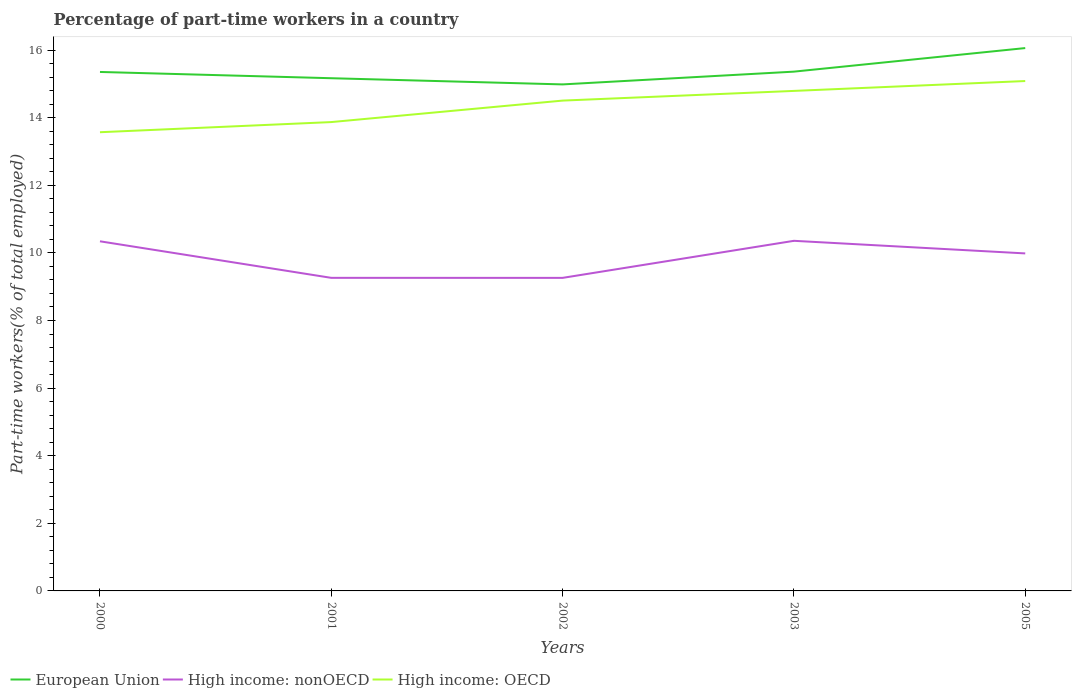Does the line corresponding to European Union intersect with the line corresponding to High income: nonOECD?
Keep it short and to the point. No. Across all years, what is the maximum percentage of part-time workers in European Union?
Give a very brief answer. 14.98. What is the total percentage of part-time workers in High income: nonOECD in the graph?
Keep it short and to the point. -1.1. What is the difference between the highest and the second highest percentage of part-time workers in European Union?
Offer a very short reply. 1.08. What is the difference between the highest and the lowest percentage of part-time workers in European Union?
Offer a very short reply. 1. How many years are there in the graph?
Your answer should be very brief. 5. What is the difference between two consecutive major ticks on the Y-axis?
Your answer should be compact. 2. Are the values on the major ticks of Y-axis written in scientific E-notation?
Offer a very short reply. No. Does the graph contain any zero values?
Offer a very short reply. No. Does the graph contain grids?
Your answer should be very brief. No. Where does the legend appear in the graph?
Offer a very short reply. Bottom left. What is the title of the graph?
Provide a short and direct response. Percentage of part-time workers in a country. Does "Samoa" appear as one of the legend labels in the graph?
Ensure brevity in your answer.  No. What is the label or title of the Y-axis?
Make the answer very short. Part-time workers(% of total employed). What is the Part-time workers(% of total employed) of European Union in 2000?
Your answer should be very brief. 15.35. What is the Part-time workers(% of total employed) in High income: nonOECD in 2000?
Your answer should be very brief. 10.34. What is the Part-time workers(% of total employed) of High income: OECD in 2000?
Your answer should be compact. 13.57. What is the Part-time workers(% of total employed) of European Union in 2001?
Your answer should be very brief. 15.17. What is the Part-time workers(% of total employed) of High income: nonOECD in 2001?
Your response must be concise. 9.26. What is the Part-time workers(% of total employed) of High income: OECD in 2001?
Your response must be concise. 13.87. What is the Part-time workers(% of total employed) of European Union in 2002?
Provide a short and direct response. 14.98. What is the Part-time workers(% of total employed) of High income: nonOECD in 2002?
Your answer should be very brief. 9.26. What is the Part-time workers(% of total employed) of High income: OECD in 2002?
Your answer should be very brief. 14.51. What is the Part-time workers(% of total employed) of European Union in 2003?
Make the answer very short. 15.36. What is the Part-time workers(% of total employed) in High income: nonOECD in 2003?
Your answer should be very brief. 10.36. What is the Part-time workers(% of total employed) in High income: OECD in 2003?
Provide a short and direct response. 14.79. What is the Part-time workers(% of total employed) in European Union in 2005?
Keep it short and to the point. 16.06. What is the Part-time workers(% of total employed) of High income: nonOECD in 2005?
Ensure brevity in your answer.  9.98. What is the Part-time workers(% of total employed) of High income: OECD in 2005?
Your response must be concise. 15.08. Across all years, what is the maximum Part-time workers(% of total employed) of European Union?
Keep it short and to the point. 16.06. Across all years, what is the maximum Part-time workers(% of total employed) in High income: nonOECD?
Provide a succinct answer. 10.36. Across all years, what is the maximum Part-time workers(% of total employed) of High income: OECD?
Your answer should be very brief. 15.08. Across all years, what is the minimum Part-time workers(% of total employed) of European Union?
Offer a terse response. 14.98. Across all years, what is the minimum Part-time workers(% of total employed) in High income: nonOECD?
Your response must be concise. 9.26. Across all years, what is the minimum Part-time workers(% of total employed) in High income: OECD?
Provide a succinct answer. 13.57. What is the total Part-time workers(% of total employed) of European Union in the graph?
Offer a terse response. 76.92. What is the total Part-time workers(% of total employed) in High income: nonOECD in the graph?
Ensure brevity in your answer.  49.21. What is the total Part-time workers(% of total employed) in High income: OECD in the graph?
Provide a short and direct response. 71.82. What is the difference between the Part-time workers(% of total employed) in European Union in 2000 and that in 2001?
Make the answer very short. 0.19. What is the difference between the Part-time workers(% of total employed) in High income: nonOECD in 2000 and that in 2001?
Your answer should be compact. 1.08. What is the difference between the Part-time workers(% of total employed) in High income: OECD in 2000 and that in 2001?
Provide a short and direct response. -0.3. What is the difference between the Part-time workers(% of total employed) in European Union in 2000 and that in 2002?
Provide a short and direct response. 0.37. What is the difference between the Part-time workers(% of total employed) in High income: nonOECD in 2000 and that in 2002?
Make the answer very short. 1.08. What is the difference between the Part-time workers(% of total employed) of High income: OECD in 2000 and that in 2002?
Your answer should be compact. -0.94. What is the difference between the Part-time workers(% of total employed) of European Union in 2000 and that in 2003?
Offer a terse response. -0.01. What is the difference between the Part-time workers(% of total employed) of High income: nonOECD in 2000 and that in 2003?
Offer a terse response. -0.01. What is the difference between the Part-time workers(% of total employed) in High income: OECD in 2000 and that in 2003?
Make the answer very short. -1.22. What is the difference between the Part-time workers(% of total employed) in European Union in 2000 and that in 2005?
Offer a terse response. -0.71. What is the difference between the Part-time workers(% of total employed) in High income: nonOECD in 2000 and that in 2005?
Your response must be concise. 0.36. What is the difference between the Part-time workers(% of total employed) in High income: OECD in 2000 and that in 2005?
Give a very brief answer. -1.51. What is the difference between the Part-time workers(% of total employed) in European Union in 2001 and that in 2002?
Make the answer very short. 0.18. What is the difference between the Part-time workers(% of total employed) in High income: nonOECD in 2001 and that in 2002?
Ensure brevity in your answer.  0. What is the difference between the Part-time workers(% of total employed) in High income: OECD in 2001 and that in 2002?
Your answer should be compact. -0.64. What is the difference between the Part-time workers(% of total employed) in European Union in 2001 and that in 2003?
Your answer should be very brief. -0.19. What is the difference between the Part-time workers(% of total employed) of High income: nonOECD in 2001 and that in 2003?
Keep it short and to the point. -1.1. What is the difference between the Part-time workers(% of total employed) in High income: OECD in 2001 and that in 2003?
Your answer should be compact. -0.92. What is the difference between the Part-time workers(% of total employed) of European Union in 2001 and that in 2005?
Provide a succinct answer. -0.89. What is the difference between the Part-time workers(% of total employed) in High income: nonOECD in 2001 and that in 2005?
Your answer should be compact. -0.72. What is the difference between the Part-time workers(% of total employed) in High income: OECD in 2001 and that in 2005?
Ensure brevity in your answer.  -1.21. What is the difference between the Part-time workers(% of total employed) of European Union in 2002 and that in 2003?
Offer a very short reply. -0.38. What is the difference between the Part-time workers(% of total employed) of High income: nonOECD in 2002 and that in 2003?
Your response must be concise. -1.1. What is the difference between the Part-time workers(% of total employed) of High income: OECD in 2002 and that in 2003?
Give a very brief answer. -0.29. What is the difference between the Part-time workers(% of total employed) of European Union in 2002 and that in 2005?
Provide a succinct answer. -1.07. What is the difference between the Part-time workers(% of total employed) of High income: nonOECD in 2002 and that in 2005?
Offer a very short reply. -0.72. What is the difference between the Part-time workers(% of total employed) in High income: OECD in 2002 and that in 2005?
Offer a very short reply. -0.58. What is the difference between the Part-time workers(% of total employed) of European Union in 2003 and that in 2005?
Keep it short and to the point. -0.7. What is the difference between the Part-time workers(% of total employed) of High income: nonOECD in 2003 and that in 2005?
Make the answer very short. 0.37. What is the difference between the Part-time workers(% of total employed) in High income: OECD in 2003 and that in 2005?
Provide a succinct answer. -0.29. What is the difference between the Part-time workers(% of total employed) of European Union in 2000 and the Part-time workers(% of total employed) of High income: nonOECD in 2001?
Provide a succinct answer. 6.09. What is the difference between the Part-time workers(% of total employed) in European Union in 2000 and the Part-time workers(% of total employed) in High income: OECD in 2001?
Provide a short and direct response. 1.48. What is the difference between the Part-time workers(% of total employed) in High income: nonOECD in 2000 and the Part-time workers(% of total employed) in High income: OECD in 2001?
Your answer should be compact. -3.53. What is the difference between the Part-time workers(% of total employed) of European Union in 2000 and the Part-time workers(% of total employed) of High income: nonOECD in 2002?
Offer a very short reply. 6.09. What is the difference between the Part-time workers(% of total employed) in European Union in 2000 and the Part-time workers(% of total employed) in High income: OECD in 2002?
Make the answer very short. 0.85. What is the difference between the Part-time workers(% of total employed) in High income: nonOECD in 2000 and the Part-time workers(% of total employed) in High income: OECD in 2002?
Your answer should be very brief. -4.16. What is the difference between the Part-time workers(% of total employed) of European Union in 2000 and the Part-time workers(% of total employed) of High income: nonOECD in 2003?
Your response must be concise. 5. What is the difference between the Part-time workers(% of total employed) in European Union in 2000 and the Part-time workers(% of total employed) in High income: OECD in 2003?
Keep it short and to the point. 0.56. What is the difference between the Part-time workers(% of total employed) in High income: nonOECD in 2000 and the Part-time workers(% of total employed) in High income: OECD in 2003?
Your answer should be compact. -4.45. What is the difference between the Part-time workers(% of total employed) in European Union in 2000 and the Part-time workers(% of total employed) in High income: nonOECD in 2005?
Offer a very short reply. 5.37. What is the difference between the Part-time workers(% of total employed) of European Union in 2000 and the Part-time workers(% of total employed) of High income: OECD in 2005?
Provide a short and direct response. 0.27. What is the difference between the Part-time workers(% of total employed) of High income: nonOECD in 2000 and the Part-time workers(% of total employed) of High income: OECD in 2005?
Offer a very short reply. -4.74. What is the difference between the Part-time workers(% of total employed) in European Union in 2001 and the Part-time workers(% of total employed) in High income: nonOECD in 2002?
Your response must be concise. 5.91. What is the difference between the Part-time workers(% of total employed) in European Union in 2001 and the Part-time workers(% of total employed) in High income: OECD in 2002?
Provide a short and direct response. 0.66. What is the difference between the Part-time workers(% of total employed) in High income: nonOECD in 2001 and the Part-time workers(% of total employed) in High income: OECD in 2002?
Provide a short and direct response. -5.24. What is the difference between the Part-time workers(% of total employed) in European Union in 2001 and the Part-time workers(% of total employed) in High income: nonOECD in 2003?
Make the answer very short. 4.81. What is the difference between the Part-time workers(% of total employed) of European Union in 2001 and the Part-time workers(% of total employed) of High income: OECD in 2003?
Provide a succinct answer. 0.38. What is the difference between the Part-time workers(% of total employed) in High income: nonOECD in 2001 and the Part-time workers(% of total employed) in High income: OECD in 2003?
Provide a short and direct response. -5.53. What is the difference between the Part-time workers(% of total employed) in European Union in 2001 and the Part-time workers(% of total employed) in High income: nonOECD in 2005?
Your answer should be compact. 5.18. What is the difference between the Part-time workers(% of total employed) in European Union in 2001 and the Part-time workers(% of total employed) in High income: OECD in 2005?
Ensure brevity in your answer.  0.08. What is the difference between the Part-time workers(% of total employed) in High income: nonOECD in 2001 and the Part-time workers(% of total employed) in High income: OECD in 2005?
Your response must be concise. -5.82. What is the difference between the Part-time workers(% of total employed) in European Union in 2002 and the Part-time workers(% of total employed) in High income: nonOECD in 2003?
Ensure brevity in your answer.  4.63. What is the difference between the Part-time workers(% of total employed) in European Union in 2002 and the Part-time workers(% of total employed) in High income: OECD in 2003?
Your answer should be very brief. 0.19. What is the difference between the Part-time workers(% of total employed) in High income: nonOECD in 2002 and the Part-time workers(% of total employed) in High income: OECD in 2003?
Ensure brevity in your answer.  -5.53. What is the difference between the Part-time workers(% of total employed) in European Union in 2002 and the Part-time workers(% of total employed) in High income: nonOECD in 2005?
Offer a very short reply. 5. What is the difference between the Part-time workers(% of total employed) in European Union in 2002 and the Part-time workers(% of total employed) in High income: OECD in 2005?
Offer a very short reply. -0.1. What is the difference between the Part-time workers(% of total employed) in High income: nonOECD in 2002 and the Part-time workers(% of total employed) in High income: OECD in 2005?
Provide a succinct answer. -5.82. What is the difference between the Part-time workers(% of total employed) in European Union in 2003 and the Part-time workers(% of total employed) in High income: nonOECD in 2005?
Provide a succinct answer. 5.38. What is the difference between the Part-time workers(% of total employed) of European Union in 2003 and the Part-time workers(% of total employed) of High income: OECD in 2005?
Your answer should be compact. 0.28. What is the difference between the Part-time workers(% of total employed) of High income: nonOECD in 2003 and the Part-time workers(% of total employed) of High income: OECD in 2005?
Keep it short and to the point. -4.73. What is the average Part-time workers(% of total employed) of European Union per year?
Provide a short and direct response. 15.38. What is the average Part-time workers(% of total employed) in High income: nonOECD per year?
Provide a succinct answer. 9.84. What is the average Part-time workers(% of total employed) of High income: OECD per year?
Offer a very short reply. 14.36. In the year 2000, what is the difference between the Part-time workers(% of total employed) of European Union and Part-time workers(% of total employed) of High income: nonOECD?
Your answer should be compact. 5.01. In the year 2000, what is the difference between the Part-time workers(% of total employed) in European Union and Part-time workers(% of total employed) in High income: OECD?
Give a very brief answer. 1.78. In the year 2000, what is the difference between the Part-time workers(% of total employed) of High income: nonOECD and Part-time workers(% of total employed) of High income: OECD?
Offer a terse response. -3.23. In the year 2001, what is the difference between the Part-time workers(% of total employed) in European Union and Part-time workers(% of total employed) in High income: nonOECD?
Your answer should be compact. 5.91. In the year 2001, what is the difference between the Part-time workers(% of total employed) of European Union and Part-time workers(% of total employed) of High income: OECD?
Your response must be concise. 1.3. In the year 2001, what is the difference between the Part-time workers(% of total employed) in High income: nonOECD and Part-time workers(% of total employed) in High income: OECD?
Your answer should be compact. -4.61. In the year 2002, what is the difference between the Part-time workers(% of total employed) of European Union and Part-time workers(% of total employed) of High income: nonOECD?
Give a very brief answer. 5.72. In the year 2002, what is the difference between the Part-time workers(% of total employed) of European Union and Part-time workers(% of total employed) of High income: OECD?
Ensure brevity in your answer.  0.48. In the year 2002, what is the difference between the Part-time workers(% of total employed) of High income: nonOECD and Part-time workers(% of total employed) of High income: OECD?
Make the answer very short. -5.24. In the year 2003, what is the difference between the Part-time workers(% of total employed) of European Union and Part-time workers(% of total employed) of High income: nonOECD?
Provide a succinct answer. 5. In the year 2003, what is the difference between the Part-time workers(% of total employed) in European Union and Part-time workers(% of total employed) in High income: OECD?
Keep it short and to the point. 0.57. In the year 2003, what is the difference between the Part-time workers(% of total employed) in High income: nonOECD and Part-time workers(% of total employed) in High income: OECD?
Your response must be concise. -4.43. In the year 2005, what is the difference between the Part-time workers(% of total employed) of European Union and Part-time workers(% of total employed) of High income: nonOECD?
Provide a short and direct response. 6.07. In the year 2005, what is the difference between the Part-time workers(% of total employed) in European Union and Part-time workers(% of total employed) in High income: OECD?
Keep it short and to the point. 0.98. In the year 2005, what is the difference between the Part-time workers(% of total employed) in High income: nonOECD and Part-time workers(% of total employed) in High income: OECD?
Your answer should be very brief. -5.1. What is the ratio of the Part-time workers(% of total employed) in European Union in 2000 to that in 2001?
Keep it short and to the point. 1.01. What is the ratio of the Part-time workers(% of total employed) in High income: nonOECD in 2000 to that in 2001?
Give a very brief answer. 1.12. What is the ratio of the Part-time workers(% of total employed) in High income: OECD in 2000 to that in 2001?
Your response must be concise. 0.98. What is the ratio of the Part-time workers(% of total employed) of European Union in 2000 to that in 2002?
Your answer should be compact. 1.02. What is the ratio of the Part-time workers(% of total employed) in High income: nonOECD in 2000 to that in 2002?
Offer a terse response. 1.12. What is the ratio of the Part-time workers(% of total employed) in High income: OECD in 2000 to that in 2002?
Offer a very short reply. 0.94. What is the ratio of the Part-time workers(% of total employed) in European Union in 2000 to that in 2003?
Your answer should be very brief. 1. What is the ratio of the Part-time workers(% of total employed) of High income: OECD in 2000 to that in 2003?
Your answer should be very brief. 0.92. What is the ratio of the Part-time workers(% of total employed) in European Union in 2000 to that in 2005?
Ensure brevity in your answer.  0.96. What is the ratio of the Part-time workers(% of total employed) in High income: nonOECD in 2000 to that in 2005?
Give a very brief answer. 1.04. What is the ratio of the Part-time workers(% of total employed) of High income: OECD in 2000 to that in 2005?
Offer a terse response. 0.9. What is the ratio of the Part-time workers(% of total employed) in European Union in 2001 to that in 2002?
Give a very brief answer. 1.01. What is the ratio of the Part-time workers(% of total employed) in High income: OECD in 2001 to that in 2002?
Offer a very short reply. 0.96. What is the ratio of the Part-time workers(% of total employed) of European Union in 2001 to that in 2003?
Your answer should be compact. 0.99. What is the ratio of the Part-time workers(% of total employed) in High income: nonOECD in 2001 to that in 2003?
Provide a short and direct response. 0.89. What is the ratio of the Part-time workers(% of total employed) in High income: OECD in 2001 to that in 2003?
Ensure brevity in your answer.  0.94. What is the ratio of the Part-time workers(% of total employed) in High income: nonOECD in 2001 to that in 2005?
Make the answer very short. 0.93. What is the ratio of the Part-time workers(% of total employed) of High income: OECD in 2001 to that in 2005?
Provide a short and direct response. 0.92. What is the ratio of the Part-time workers(% of total employed) of European Union in 2002 to that in 2003?
Provide a succinct answer. 0.98. What is the ratio of the Part-time workers(% of total employed) in High income: nonOECD in 2002 to that in 2003?
Your response must be concise. 0.89. What is the ratio of the Part-time workers(% of total employed) of High income: OECD in 2002 to that in 2003?
Offer a very short reply. 0.98. What is the ratio of the Part-time workers(% of total employed) of European Union in 2002 to that in 2005?
Make the answer very short. 0.93. What is the ratio of the Part-time workers(% of total employed) in High income: nonOECD in 2002 to that in 2005?
Offer a terse response. 0.93. What is the ratio of the Part-time workers(% of total employed) in High income: OECD in 2002 to that in 2005?
Your response must be concise. 0.96. What is the ratio of the Part-time workers(% of total employed) in European Union in 2003 to that in 2005?
Provide a short and direct response. 0.96. What is the ratio of the Part-time workers(% of total employed) in High income: nonOECD in 2003 to that in 2005?
Your answer should be very brief. 1.04. What is the ratio of the Part-time workers(% of total employed) in High income: OECD in 2003 to that in 2005?
Give a very brief answer. 0.98. What is the difference between the highest and the second highest Part-time workers(% of total employed) in European Union?
Your answer should be compact. 0.7. What is the difference between the highest and the second highest Part-time workers(% of total employed) in High income: nonOECD?
Make the answer very short. 0.01. What is the difference between the highest and the second highest Part-time workers(% of total employed) of High income: OECD?
Keep it short and to the point. 0.29. What is the difference between the highest and the lowest Part-time workers(% of total employed) in European Union?
Provide a short and direct response. 1.07. What is the difference between the highest and the lowest Part-time workers(% of total employed) in High income: nonOECD?
Provide a succinct answer. 1.1. What is the difference between the highest and the lowest Part-time workers(% of total employed) of High income: OECD?
Your answer should be compact. 1.51. 